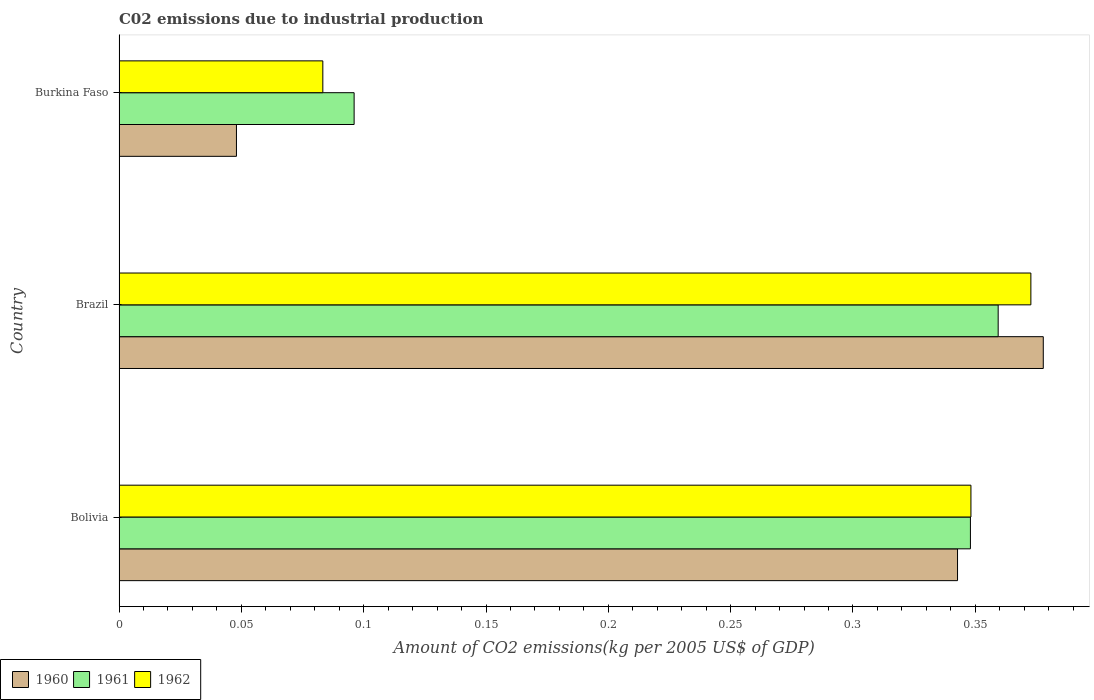How many groups of bars are there?
Offer a terse response. 3. How many bars are there on the 1st tick from the bottom?
Give a very brief answer. 3. What is the label of the 1st group of bars from the top?
Provide a short and direct response. Burkina Faso. What is the amount of CO2 emitted due to industrial production in 1960 in Bolivia?
Provide a succinct answer. 0.34. Across all countries, what is the maximum amount of CO2 emitted due to industrial production in 1962?
Provide a short and direct response. 0.37. Across all countries, what is the minimum amount of CO2 emitted due to industrial production in 1962?
Offer a terse response. 0.08. In which country was the amount of CO2 emitted due to industrial production in 1960 maximum?
Give a very brief answer. Brazil. In which country was the amount of CO2 emitted due to industrial production in 1962 minimum?
Your answer should be compact. Burkina Faso. What is the total amount of CO2 emitted due to industrial production in 1961 in the graph?
Your answer should be very brief. 0.8. What is the difference between the amount of CO2 emitted due to industrial production in 1961 in Bolivia and that in Brazil?
Your response must be concise. -0.01. What is the difference between the amount of CO2 emitted due to industrial production in 1961 in Burkina Faso and the amount of CO2 emitted due to industrial production in 1960 in Bolivia?
Your answer should be very brief. -0.25. What is the average amount of CO2 emitted due to industrial production in 1961 per country?
Your response must be concise. 0.27. What is the difference between the amount of CO2 emitted due to industrial production in 1960 and amount of CO2 emitted due to industrial production in 1962 in Brazil?
Offer a very short reply. 0.01. In how many countries, is the amount of CO2 emitted due to industrial production in 1962 greater than 0.27 kg?
Give a very brief answer. 2. What is the ratio of the amount of CO2 emitted due to industrial production in 1962 in Bolivia to that in Burkina Faso?
Provide a succinct answer. 4.18. Is the amount of CO2 emitted due to industrial production in 1962 in Bolivia less than that in Burkina Faso?
Keep it short and to the point. No. What is the difference between the highest and the second highest amount of CO2 emitted due to industrial production in 1961?
Give a very brief answer. 0.01. What is the difference between the highest and the lowest amount of CO2 emitted due to industrial production in 1960?
Offer a very short reply. 0.33. What does the 3rd bar from the top in Burkina Faso represents?
Keep it short and to the point. 1960. What does the 3rd bar from the bottom in Burkina Faso represents?
Offer a terse response. 1962. Is it the case that in every country, the sum of the amount of CO2 emitted due to industrial production in 1961 and amount of CO2 emitted due to industrial production in 1960 is greater than the amount of CO2 emitted due to industrial production in 1962?
Offer a terse response. Yes. How many bars are there?
Make the answer very short. 9. Are all the bars in the graph horizontal?
Your response must be concise. Yes. How many countries are there in the graph?
Make the answer very short. 3. Are the values on the major ticks of X-axis written in scientific E-notation?
Provide a short and direct response. No. Does the graph contain any zero values?
Provide a short and direct response. No. Does the graph contain grids?
Your response must be concise. No. Where does the legend appear in the graph?
Your answer should be very brief. Bottom left. How many legend labels are there?
Make the answer very short. 3. How are the legend labels stacked?
Offer a very short reply. Horizontal. What is the title of the graph?
Your answer should be compact. C02 emissions due to industrial production. What is the label or title of the X-axis?
Provide a succinct answer. Amount of CO2 emissions(kg per 2005 US$ of GDP). What is the Amount of CO2 emissions(kg per 2005 US$ of GDP) of 1960 in Bolivia?
Your answer should be very brief. 0.34. What is the Amount of CO2 emissions(kg per 2005 US$ of GDP) in 1961 in Bolivia?
Make the answer very short. 0.35. What is the Amount of CO2 emissions(kg per 2005 US$ of GDP) in 1962 in Bolivia?
Provide a succinct answer. 0.35. What is the Amount of CO2 emissions(kg per 2005 US$ of GDP) of 1960 in Brazil?
Your response must be concise. 0.38. What is the Amount of CO2 emissions(kg per 2005 US$ of GDP) in 1961 in Brazil?
Provide a short and direct response. 0.36. What is the Amount of CO2 emissions(kg per 2005 US$ of GDP) in 1962 in Brazil?
Provide a short and direct response. 0.37. What is the Amount of CO2 emissions(kg per 2005 US$ of GDP) of 1960 in Burkina Faso?
Offer a terse response. 0.05. What is the Amount of CO2 emissions(kg per 2005 US$ of GDP) of 1961 in Burkina Faso?
Your answer should be very brief. 0.1. What is the Amount of CO2 emissions(kg per 2005 US$ of GDP) in 1962 in Burkina Faso?
Provide a succinct answer. 0.08. Across all countries, what is the maximum Amount of CO2 emissions(kg per 2005 US$ of GDP) of 1960?
Provide a succinct answer. 0.38. Across all countries, what is the maximum Amount of CO2 emissions(kg per 2005 US$ of GDP) in 1961?
Provide a short and direct response. 0.36. Across all countries, what is the maximum Amount of CO2 emissions(kg per 2005 US$ of GDP) of 1962?
Provide a succinct answer. 0.37. Across all countries, what is the minimum Amount of CO2 emissions(kg per 2005 US$ of GDP) of 1960?
Your answer should be compact. 0.05. Across all countries, what is the minimum Amount of CO2 emissions(kg per 2005 US$ of GDP) of 1961?
Make the answer very short. 0.1. Across all countries, what is the minimum Amount of CO2 emissions(kg per 2005 US$ of GDP) of 1962?
Ensure brevity in your answer.  0.08. What is the total Amount of CO2 emissions(kg per 2005 US$ of GDP) in 1960 in the graph?
Give a very brief answer. 0.77. What is the total Amount of CO2 emissions(kg per 2005 US$ of GDP) in 1961 in the graph?
Give a very brief answer. 0.8. What is the total Amount of CO2 emissions(kg per 2005 US$ of GDP) of 1962 in the graph?
Ensure brevity in your answer.  0.8. What is the difference between the Amount of CO2 emissions(kg per 2005 US$ of GDP) of 1960 in Bolivia and that in Brazil?
Your response must be concise. -0.04. What is the difference between the Amount of CO2 emissions(kg per 2005 US$ of GDP) in 1961 in Bolivia and that in Brazil?
Offer a very short reply. -0.01. What is the difference between the Amount of CO2 emissions(kg per 2005 US$ of GDP) of 1962 in Bolivia and that in Brazil?
Offer a terse response. -0.02. What is the difference between the Amount of CO2 emissions(kg per 2005 US$ of GDP) in 1960 in Bolivia and that in Burkina Faso?
Keep it short and to the point. 0.29. What is the difference between the Amount of CO2 emissions(kg per 2005 US$ of GDP) in 1961 in Bolivia and that in Burkina Faso?
Your response must be concise. 0.25. What is the difference between the Amount of CO2 emissions(kg per 2005 US$ of GDP) in 1962 in Bolivia and that in Burkina Faso?
Your answer should be very brief. 0.26. What is the difference between the Amount of CO2 emissions(kg per 2005 US$ of GDP) in 1960 in Brazil and that in Burkina Faso?
Give a very brief answer. 0.33. What is the difference between the Amount of CO2 emissions(kg per 2005 US$ of GDP) in 1961 in Brazil and that in Burkina Faso?
Provide a succinct answer. 0.26. What is the difference between the Amount of CO2 emissions(kg per 2005 US$ of GDP) in 1962 in Brazil and that in Burkina Faso?
Provide a short and direct response. 0.29. What is the difference between the Amount of CO2 emissions(kg per 2005 US$ of GDP) in 1960 in Bolivia and the Amount of CO2 emissions(kg per 2005 US$ of GDP) in 1961 in Brazil?
Your response must be concise. -0.02. What is the difference between the Amount of CO2 emissions(kg per 2005 US$ of GDP) of 1960 in Bolivia and the Amount of CO2 emissions(kg per 2005 US$ of GDP) of 1962 in Brazil?
Offer a terse response. -0.03. What is the difference between the Amount of CO2 emissions(kg per 2005 US$ of GDP) in 1961 in Bolivia and the Amount of CO2 emissions(kg per 2005 US$ of GDP) in 1962 in Brazil?
Your answer should be compact. -0.02. What is the difference between the Amount of CO2 emissions(kg per 2005 US$ of GDP) in 1960 in Bolivia and the Amount of CO2 emissions(kg per 2005 US$ of GDP) in 1961 in Burkina Faso?
Your answer should be very brief. 0.25. What is the difference between the Amount of CO2 emissions(kg per 2005 US$ of GDP) in 1960 in Bolivia and the Amount of CO2 emissions(kg per 2005 US$ of GDP) in 1962 in Burkina Faso?
Offer a terse response. 0.26. What is the difference between the Amount of CO2 emissions(kg per 2005 US$ of GDP) in 1961 in Bolivia and the Amount of CO2 emissions(kg per 2005 US$ of GDP) in 1962 in Burkina Faso?
Offer a very short reply. 0.26. What is the difference between the Amount of CO2 emissions(kg per 2005 US$ of GDP) of 1960 in Brazil and the Amount of CO2 emissions(kg per 2005 US$ of GDP) of 1961 in Burkina Faso?
Provide a short and direct response. 0.28. What is the difference between the Amount of CO2 emissions(kg per 2005 US$ of GDP) of 1960 in Brazil and the Amount of CO2 emissions(kg per 2005 US$ of GDP) of 1962 in Burkina Faso?
Your answer should be very brief. 0.29. What is the difference between the Amount of CO2 emissions(kg per 2005 US$ of GDP) of 1961 in Brazil and the Amount of CO2 emissions(kg per 2005 US$ of GDP) of 1962 in Burkina Faso?
Provide a succinct answer. 0.28. What is the average Amount of CO2 emissions(kg per 2005 US$ of GDP) in 1960 per country?
Provide a short and direct response. 0.26. What is the average Amount of CO2 emissions(kg per 2005 US$ of GDP) of 1961 per country?
Offer a very short reply. 0.27. What is the average Amount of CO2 emissions(kg per 2005 US$ of GDP) in 1962 per country?
Provide a succinct answer. 0.27. What is the difference between the Amount of CO2 emissions(kg per 2005 US$ of GDP) in 1960 and Amount of CO2 emissions(kg per 2005 US$ of GDP) in 1961 in Bolivia?
Give a very brief answer. -0.01. What is the difference between the Amount of CO2 emissions(kg per 2005 US$ of GDP) of 1960 and Amount of CO2 emissions(kg per 2005 US$ of GDP) of 1962 in Bolivia?
Give a very brief answer. -0.01. What is the difference between the Amount of CO2 emissions(kg per 2005 US$ of GDP) of 1961 and Amount of CO2 emissions(kg per 2005 US$ of GDP) of 1962 in Bolivia?
Your answer should be compact. -0. What is the difference between the Amount of CO2 emissions(kg per 2005 US$ of GDP) of 1960 and Amount of CO2 emissions(kg per 2005 US$ of GDP) of 1961 in Brazil?
Offer a terse response. 0.02. What is the difference between the Amount of CO2 emissions(kg per 2005 US$ of GDP) of 1960 and Amount of CO2 emissions(kg per 2005 US$ of GDP) of 1962 in Brazil?
Your answer should be compact. 0.01. What is the difference between the Amount of CO2 emissions(kg per 2005 US$ of GDP) in 1961 and Amount of CO2 emissions(kg per 2005 US$ of GDP) in 1962 in Brazil?
Make the answer very short. -0.01. What is the difference between the Amount of CO2 emissions(kg per 2005 US$ of GDP) of 1960 and Amount of CO2 emissions(kg per 2005 US$ of GDP) of 1961 in Burkina Faso?
Make the answer very short. -0.05. What is the difference between the Amount of CO2 emissions(kg per 2005 US$ of GDP) in 1960 and Amount of CO2 emissions(kg per 2005 US$ of GDP) in 1962 in Burkina Faso?
Offer a very short reply. -0.04. What is the difference between the Amount of CO2 emissions(kg per 2005 US$ of GDP) in 1961 and Amount of CO2 emissions(kg per 2005 US$ of GDP) in 1962 in Burkina Faso?
Your answer should be very brief. 0.01. What is the ratio of the Amount of CO2 emissions(kg per 2005 US$ of GDP) in 1960 in Bolivia to that in Brazil?
Your response must be concise. 0.91. What is the ratio of the Amount of CO2 emissions(kg per 2005 US$ of GDP) in 1961 in Bolivia to that in Brazil?
Offer a very short reply. 0.97. What is the ratio of the Amount of CO2 emissions(kg per 2005 US$ of GDP) of 1962 in Bolivia to that in Brazil?
Make the answer very short. 0.93. What is the ratio of the Amount of CO2 emissions(kg per 2005 US$ of GDP) in 1960 in Bolivia to that in Burkina Faso?
Make the answer very short. 7.14. What is the ratio of the Amount of CO2 emissions(kg per 2005 US$ of GDP) in 1961 in Bolivia to that in Burkina Faso?
Your answer should be very brief. 3.62. What is the ratio of the Amount of CO2 emissions(kg per 2005 US$ of GDP) of 1962 in Bolivia to that in Burkina Faso?
Offer a very short reply. 4.18. What is the ratio of the Amount of CO2 emissions(kg per 2005 US$ of GDP) of 1960 in Brazil to that in Burkina Faso?
Provide a short and direct response. 7.87. What is the ratio of the Amount of CO2 emissions(kg per 2005 US$ of GDP) in 1961 in Brazil to that in Burkina Faso?
Provide a succinct answer. 3.74. What is the ratio of the Amount of CO2 emissions(kg per 2005 US$ of GDP) of 1962 in Brazil to that in Burkina Faso?
Your response must be concise. 4.47. What is the difference between the highest and the second highest Amount of CO2 emissions(kg per 2005 US$ of GDP) in 1960?
Provide a succinct answer. 0.04. What is the difference between the highest and the second highest Amount of CO2 emissions(kg per 2005 US$ of GDP) in 1961?
Keep it short and to the point. 0.01. What is the difference between the highest and the second highest Amount of CO2 emissions(kg per 2005 US$ of GDP) of 1962?
Your answer should be compact. 0.02. What is the difference between the highest and the lowest Amount of CO2 emissions(kg per 2005 US$ of GDP) in 1960?
Make the answer very short. 0.33. What is the difference between the highest and the lowest Amount of CO2 emissions(kg per 2005 US$ of GDP) in 1961?
Your response must be concise. 0.26. What is the difference between the highest and the lowest Amount of CO2 emissions(kg per 2005 US$ of GDP) in 1962?
Make the answer very short. 0.29. 